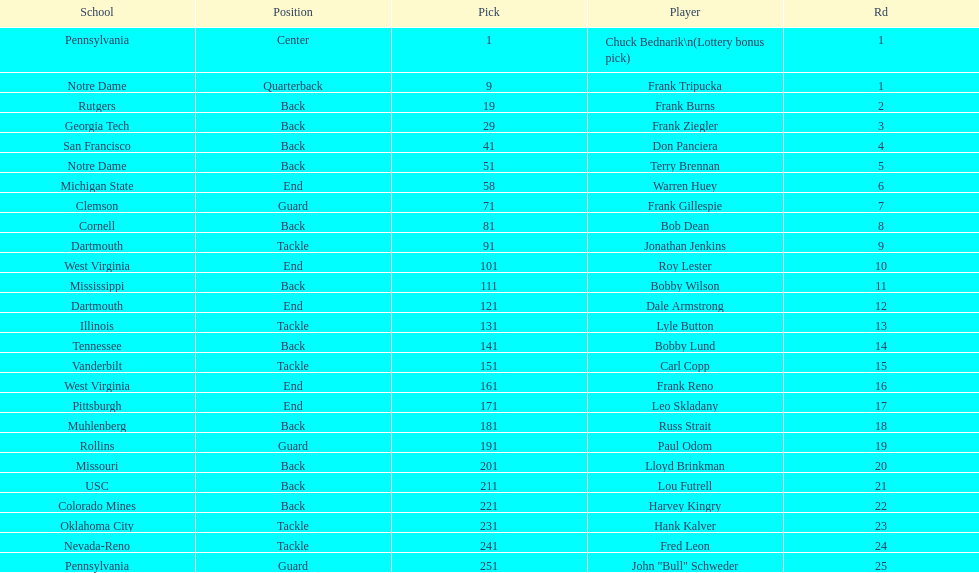How many players were from notre dame? 2. Help me parse the entirety of this table. {'header': ['School', 'Position', 'Pick', 'Player', 'Rd'], 'rows': [['Pennsylvania', 'Center', '1', 'Chuck Bednarik\\n(Lottery bonus pick)', '1'], ['Notre Dame', 'Quarterback', '9', 'Frank Tripucka', '1'], ['Rutgers', 'Back', '19', 'Frank Burns', '2'], ['Georgia Tech', 'Back', '29', 'Frank Ziegler', '3'], ['San Francisco', 'Back', '41', 'Don Panciera', '4'], ['Notre Dame', 'Back', '51', 'Terry Brennan', '5'], ['Michigan State', 'End', '58', 'Warren Huey', '6'], ['Clemson', 'Guard', '71', 'Frank Gillespie', '7'], ['Cornell', 'Back', '81', 'Bob Dean', '8'], ['Dartmouth', 'Tackle', '91', 'Jonathan Jenkins', '9'], ['West Virginia', 'End', '101', 'Roy Lester', '10'], ['Mississippi', 'Back', '111', 'Bobby Wilson', '11'], ['Dartmouth', 'End', '121', 'Dale Armstrong', '12'], ['Illinois', 'Tackle', '131', 'Lyle Button', '13'], ['Tennessee', 'Back', '141', 'Bobby Lund', '14'], ['Vanderbilt', 'Tackle', '151', 'Carl Copp', '15'], ['West Virginia', 'End', '161', 'Frank Reno', '16'], ['Pittsburgh', 'End', '171', 'Leo Skladany', '17'], ['Muhlenberg', 'Back', '181', 'Russ Strait', '18'], ['Rollins', 'Guard', '191', 'Paul Odom', '19'], ['Missouri', 'Back', '201', 'Lloyd Brinkman', '20'], ['USC', 'Back', '211', 'Lou Futrell', '21'], ['Colorado Mines', 'Back', '221', 'Harvey Kingry', '22'], ['Oklahoma City', 'Tackle', '231', 'Hank Kalver', '23'], ['Nevada-Reno', 'Tackle', '241', 'Fred Leon', '24'], ['Pennsylvania', 'Guard', '251', 'John "Bull" Schweder', '25']]} 